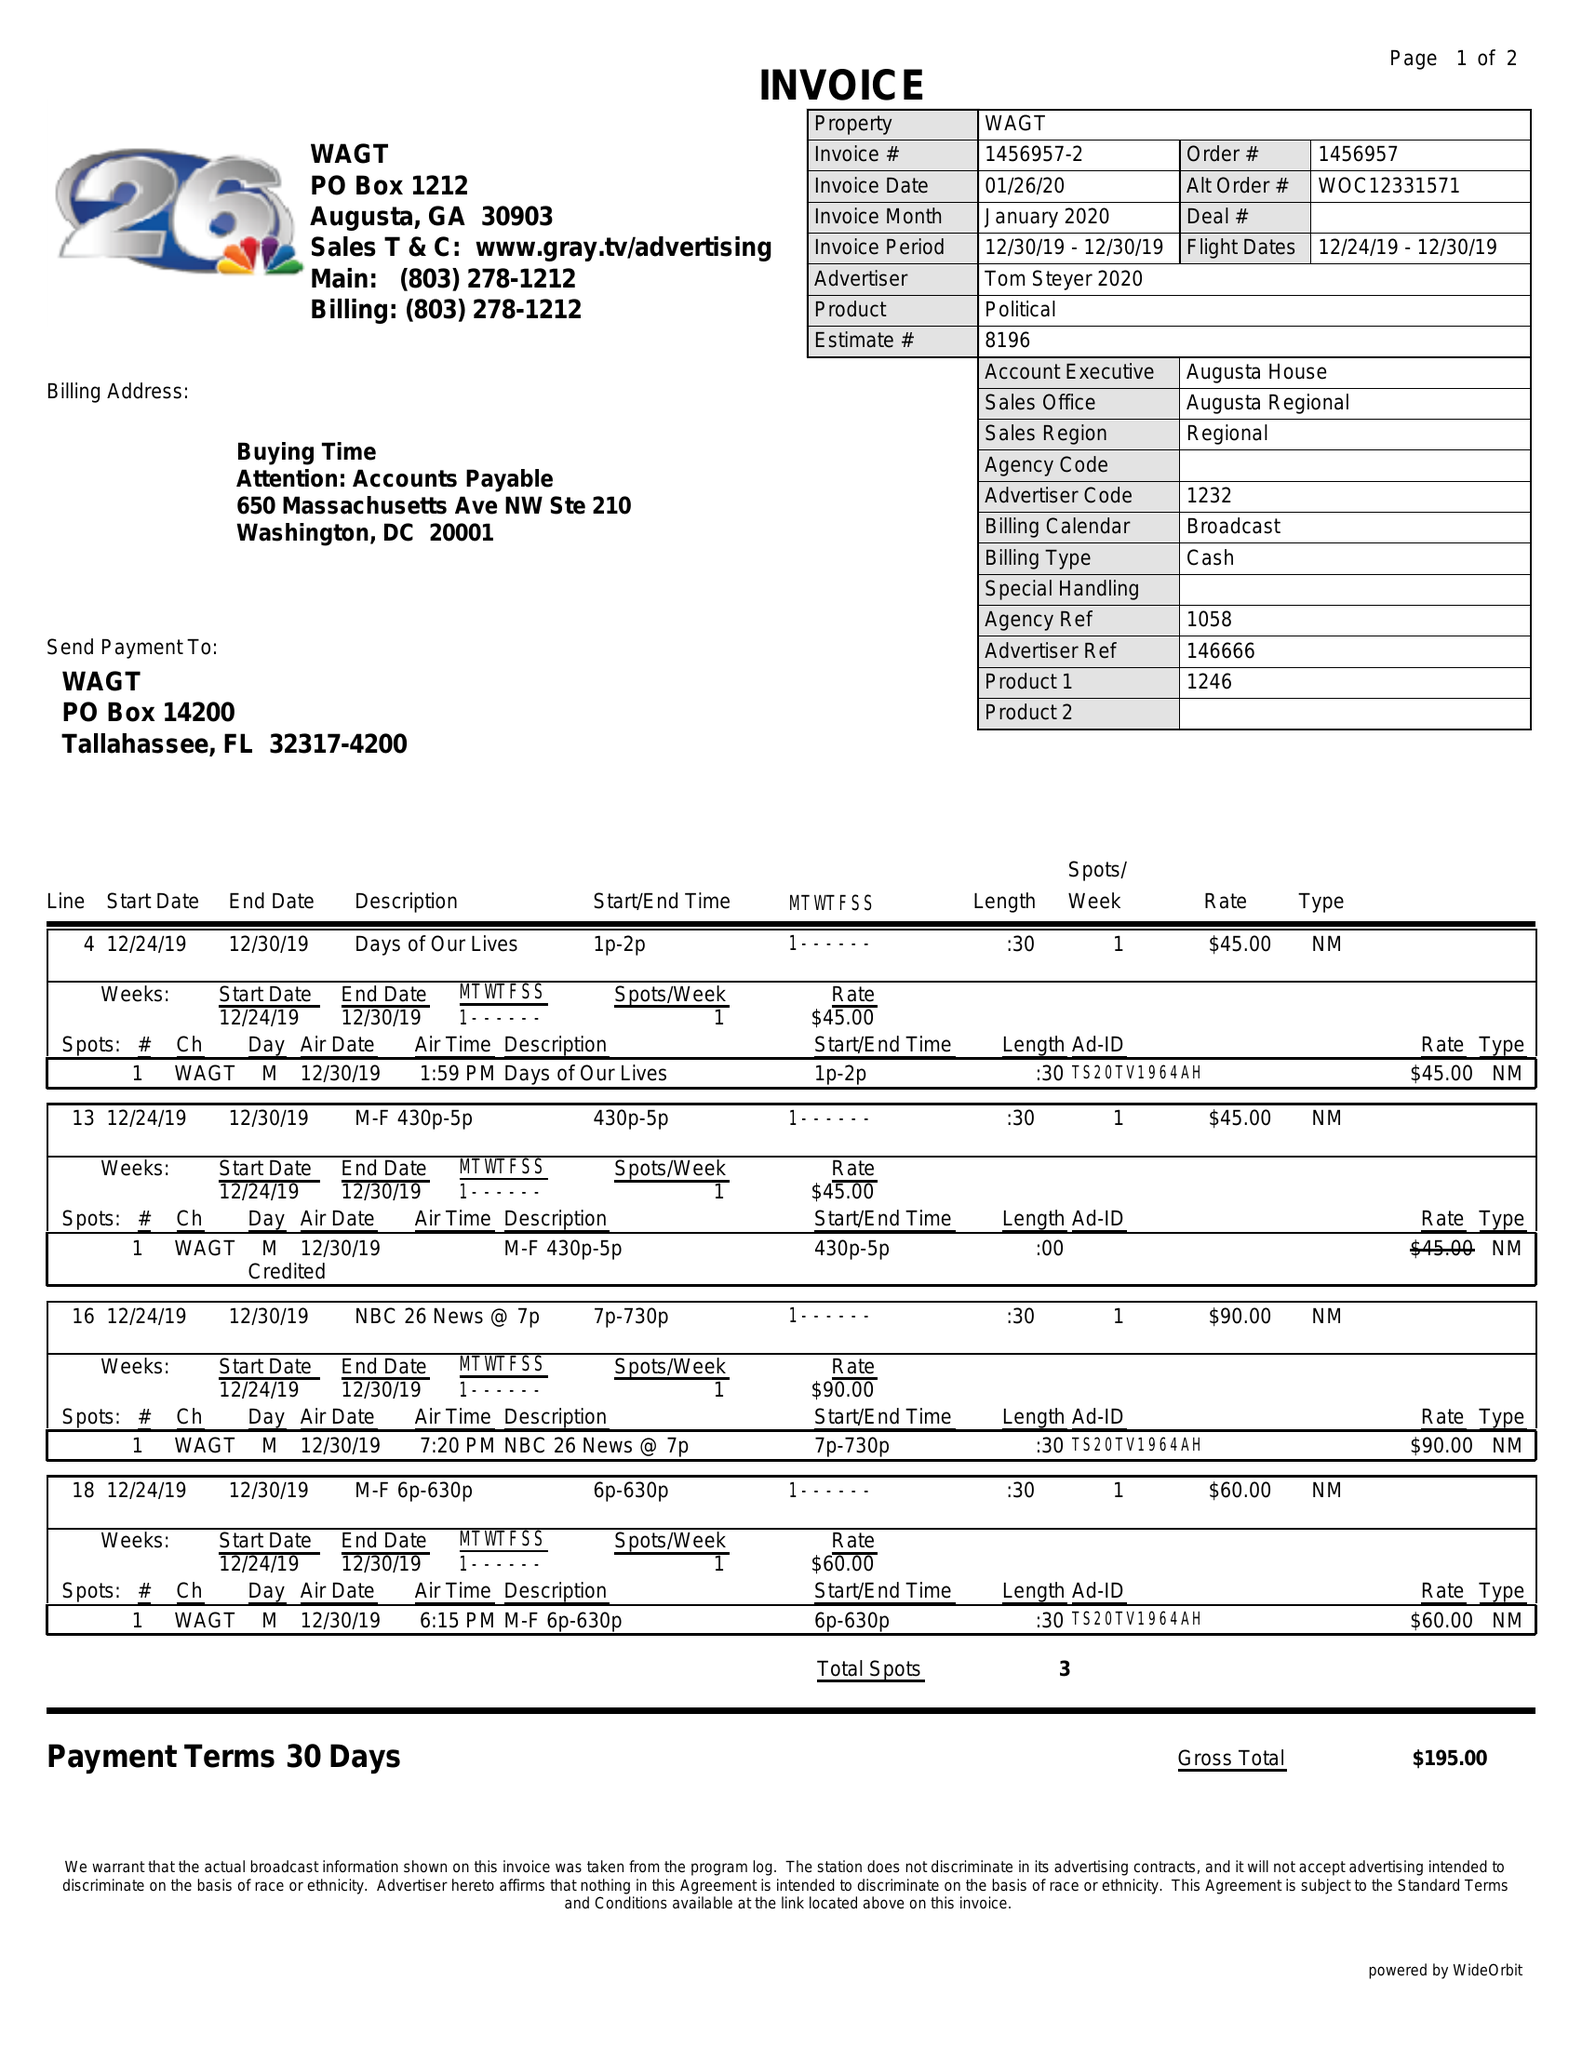What is the value for the advertiser?
Answer the question using a single word or phrase. TOM STEYER 2020 